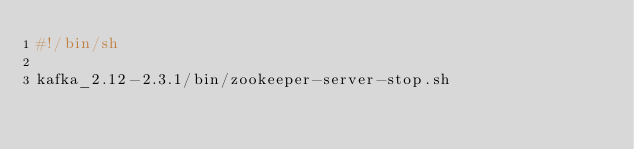Convert code to text. <code><loc_0><loc_0><loc_500><loc_500><_Bash_>#!/bin/sh

kafka_2.12-2.3.1/bin/zookeeper-server-stop.sh
</code> 